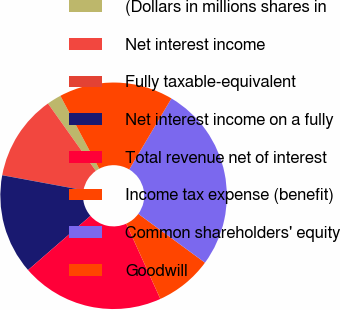<chart> <loc_0><loc_0><loc_500><loc_500><pie_chart><fcel>(Dollars in millions shares in<fcel>Net interest income<fcel>Fully taxable-equivalent<fcel>Net interest income on a fully<fcel>Total revenue net of interest<fcel>Income tax expense (benefit)<fcel>Common shareholders' equity<fcel>Goodwill<nl><fcel>2.05%<fcel>12.25%<fcel>0.01%<fcel>14.28%<fcel>20.4%<fcel>8.17%<fcel>26.52%<fcel>16.32%<nl></chart> 